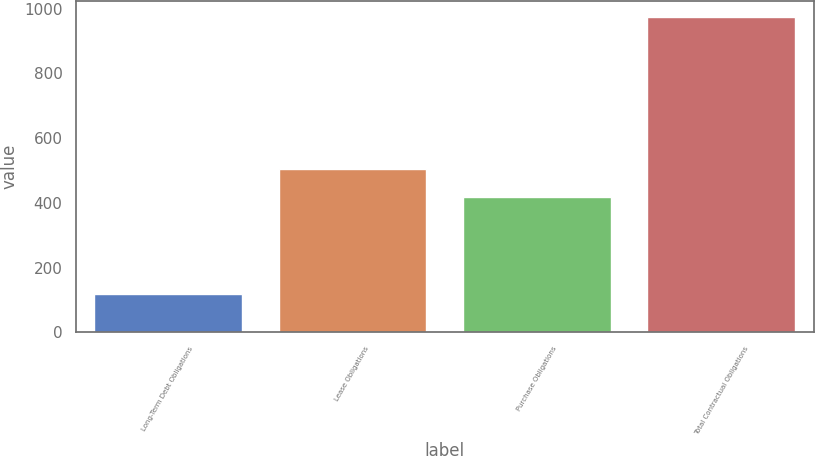<chart> <loc_0><loc_0><loc_500><loc_500><bar_chart><fcel>Long-Term Debt Obligations<fcel>Lease Obligations<fcel>Purchase Obligations<fcel>Total Contractual Obligations<nl><fcel>119<fcel>503.6<fcel>418<fcel>975<nl></chart> 